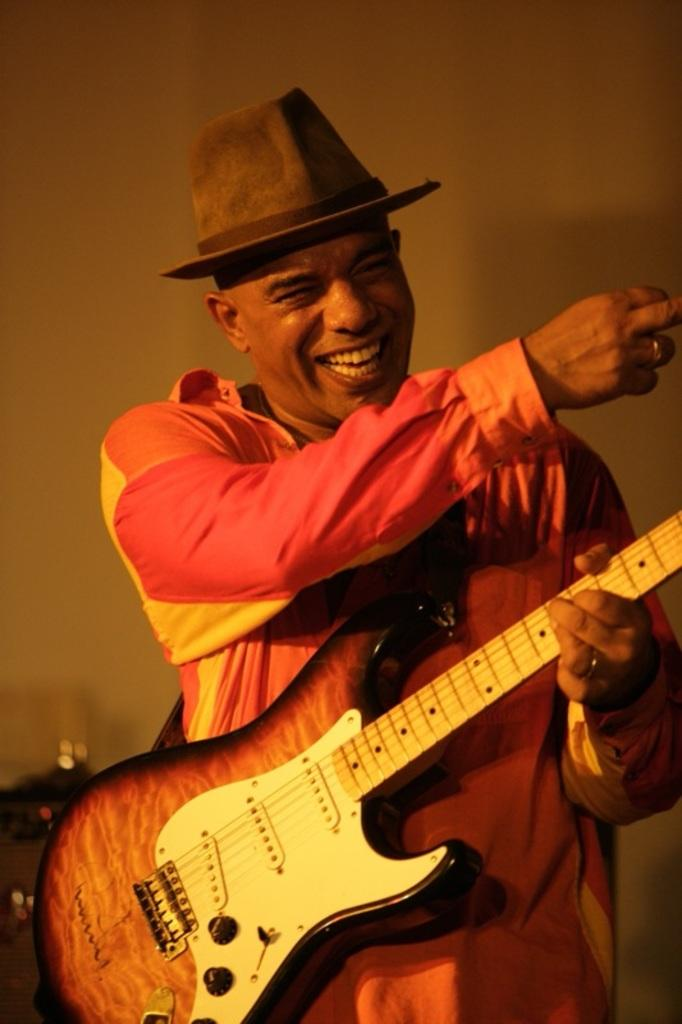What is the main subject of the image? The main subject of the image is a man. What is the man wearing in the image? The man is wearing a pink shirt and a hat on his head. What is the man holding in the image? The man is holding a guitar in his hand. What is the man's facial expression in the image? The man is laughing in the image. What type of bells can be heard ringing in the image? There are no bells present in the image, and therefore no sound can be heard. Can you see a giraffe in the image? No, there is no giraffe present in the image. 